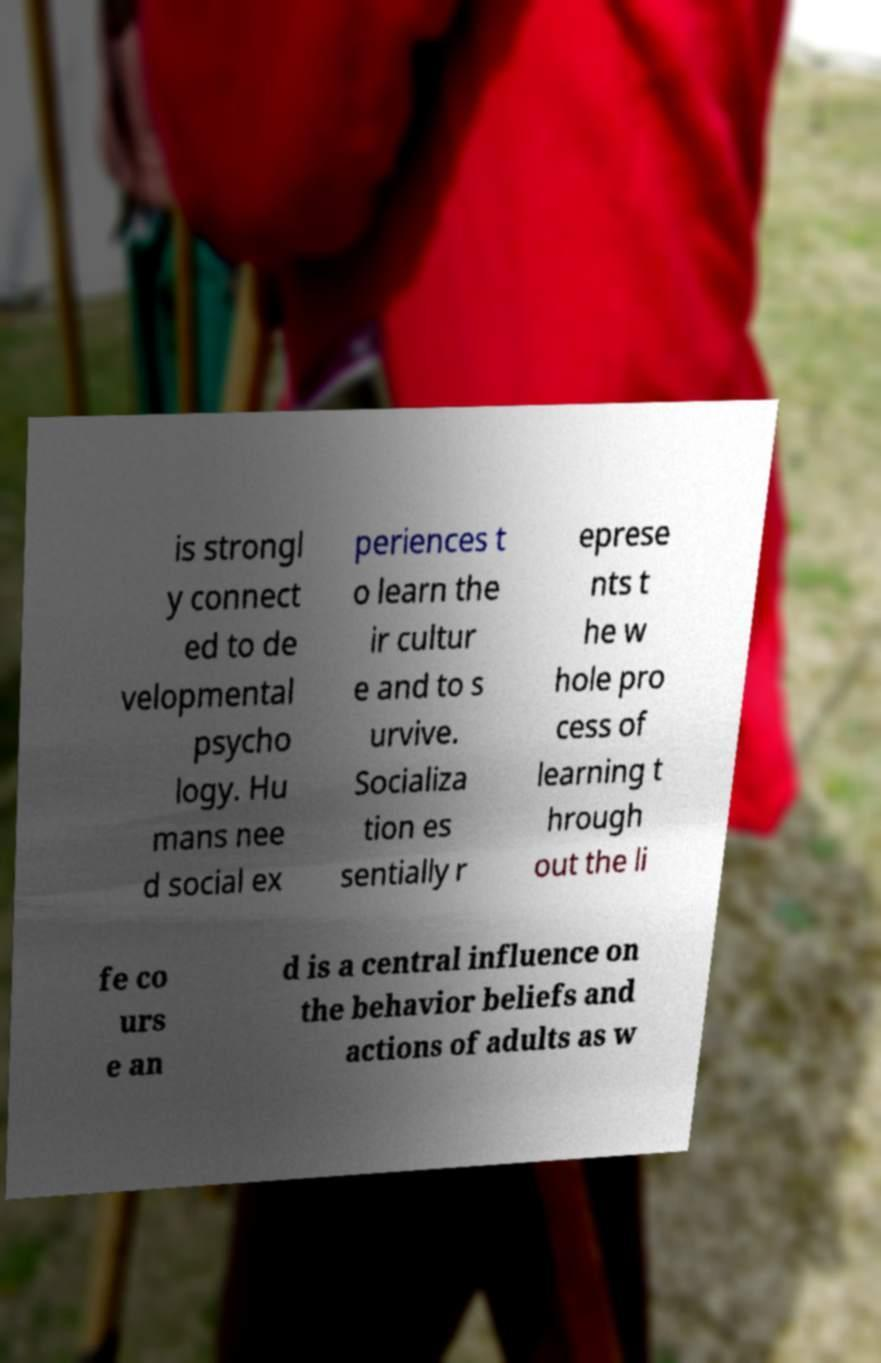What messages or text are displayed in this image? I need them in a readable, typed format. is strongl y connect ed to de velopmental psycho logy. Hu mans nee d social ex periences t o learn the ir cultur e and to s urvive. Socializa tion es sentially r eprese nts t he w hole pro cess of learning t hrough out the li fe co urs e an d is a central influence on the behavior beliefs and actions of adults as w 